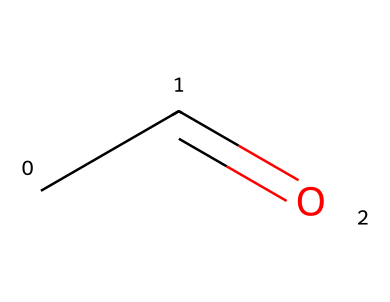What is the molecular formula of acetaldehyde? The SMILES representation CC=O indicates the presence of two carbon atoms (C), four hydrogen atoms (H), and one oxygen atom (O). Thus, the molecular formula is obtained by counting these atoms.
Answer: C2H4O How many carbon atoms are present in acetaldehyde? From the SMILES notation CC=O, the two "C" symbols represent two carbon atoms, which can be directly counted.
Answer: 2 What type of functional group does acetaldehyde possess? The presence of the carbonyl group (C=O) in the structure indicates that acetaldehyde falls under the functional group known as aldehydes, which specifically features a carbon atom double-bonded to an oxygen atom and single-bonded to a hydrogen atom.
Answer: aldehyde What is the total number of hydrogen atoms in acetaldehyde? The SMILES notation shows each carbon (C) is bonded to a number of hydrogen (H) atoms; the first carbon is connected to three hydrogens and the second carbon is connected to one hydrogen. Counting these indicates that there are four hydrogen atoms in total.
Answer: 4 What bond type is formed between the carbon and oxygen in acetaldehyde? The SMILES representation illustrates a double bond between the carbon atom and the oxygen atom (C=O), which is characteristic of a carbonyl group typically found in aldehydes.
Answer: double bond Does acetaldehyde have a branched or straight-chain structure? The linear appearance of the SMILES representation CC=O suggests that the structure of acetaldehyde is straight-chain, as there are no branches or additional carbon atoms connecting off the main carbon chain.
Answer: straight-chain 